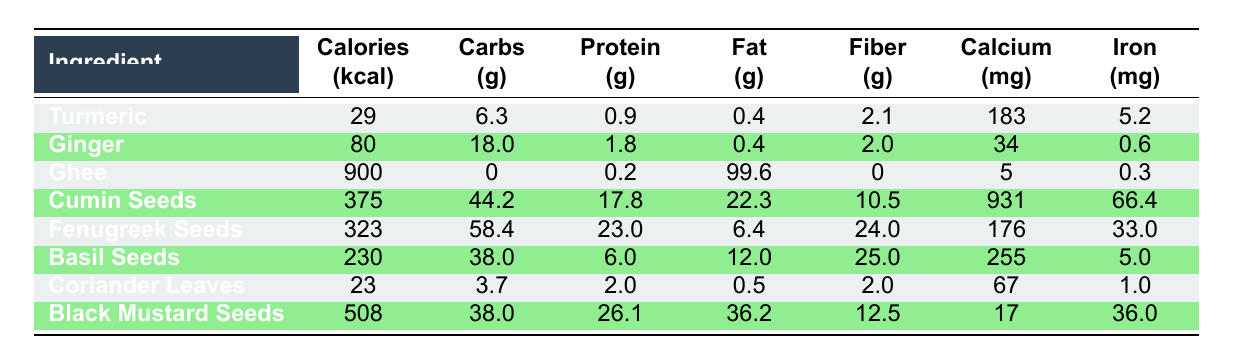What is the caloric content of Fenugreek Seeds? The table shows that Fenugreek Seeds have 323 calories listed under the Calories column.
Answer: 323 Which ingredient has the highest fat content? Looking at the Fat column, Ghee has 99.6 grams of fat, which is higher than any other ingredient.
Answer: Ghee What is the total carbohydrate content of Cumin Seeds and Ginger combined? The carbohydrate content for Cumin Seeds is 44.2 grams and for Ginger is 18.0 grams. Adding these gives 44.2 + 18.0 = 62.2 grams.
Answer: 62.2 Does Turmeric contain any Vitamin E? Referring to the Vitamins section for Turmeric, it shows 0.1 grams of Vitamin E. Thus, it does contain Vitamin E.
Answer: Yes Which ingredient has the most amount of Protein? The table shows that Black Mustard Seeds have 26.1 grams of protein, which is higher than the others.
Answer: Black Mustard Seeds What is the average calorie content of all the ingredients listed? To find the average calories, sum all the calorie contents: (29 + 80 + 900 + 375 + 323 + 230 + 23 + 508) = 2468. There are 8 ingredients, so the average calories = 2468 / 8 = 308.5.
Answer: 308.5 How much more calcium does Cumin Seeds have compared to Ginger? The calcium content for Cumin Seeds is 931 mg and for Ginger is 34 mg. The difference is 931 - 34 = 897 mg.
Answer: 897 mg Is the Iron content of Ghee greater than that of Turmeric? Ghee has 0.3 mg iron and Turmeric has 5.2 mg. Since 0.3 is less than 5.2, it is not greater.
Answer: No What percentage of the total fiber content comes from Ginger and Basil Seeds combined? Fiber content is 2.0 grams for Ginger and 25.0 grams for Basil Seeds. Their total fiber is 27.0 grams. The total fiber from all ingredients is (2.1 + 2.0 + 0 + 10.5 + 24.0 + 25.0 + 2.0 + 12.5) = 76.1 grams. The percentage is (27.0 / 76.1) * 100 ≈ 35.5%.
Answer: 35.5% Which ingredient has the lowest amount of calories? The table indicates that Coriander Leaves have the least calories at 23.
Answer: Coriander Leaves 